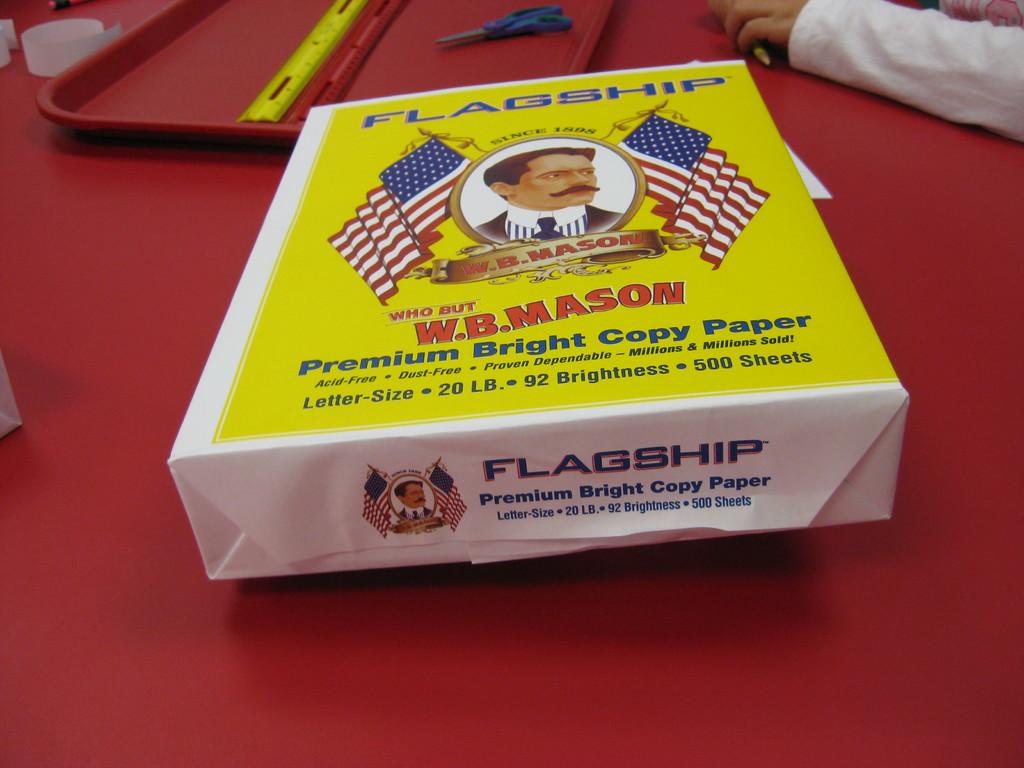What is the name of the guy?
Provide a short and direct response. W.b. mason. What type of paper is this?
Your answer should be very brief. Premium bright copy paper. 